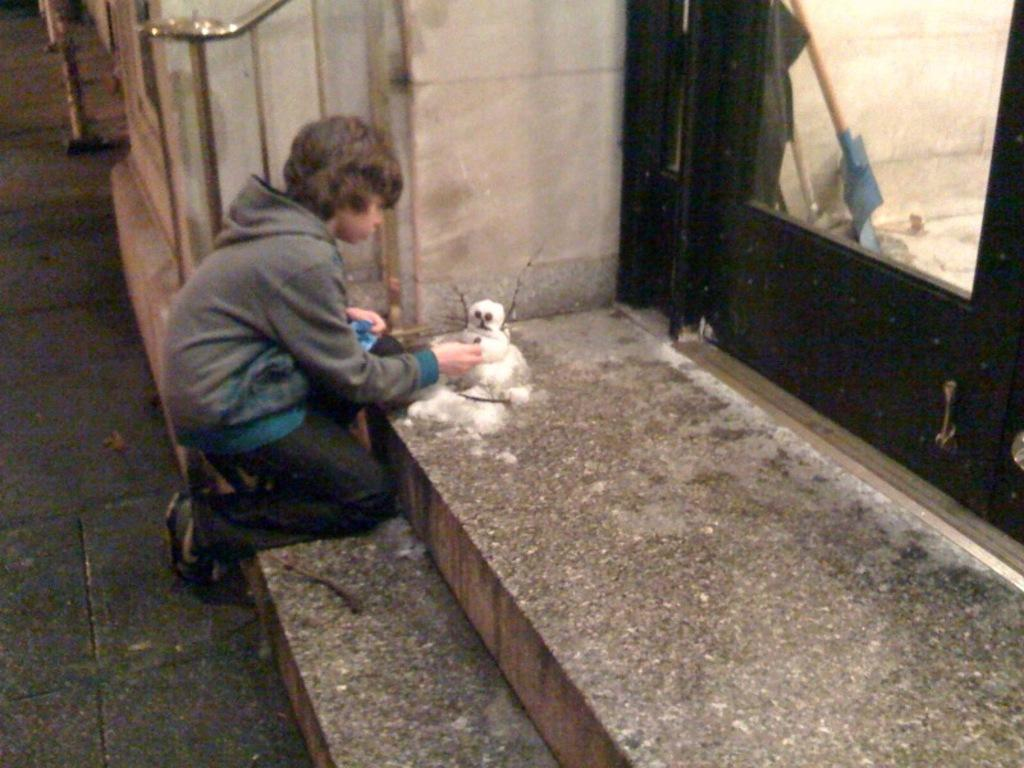What is the main subject of the image? There is a kid in the center of the image. What is the kid holding in the image? The kid is holding some objects. What is in front of the kid? There is a snowman in front of the kid. What can be seen in the background of the image? There is a wall and other objects visible in the background. What type of liquid is being used to draw on the wall in the image? There is no liquid being used to draw on the wall in the image. What kind of chalk is the kid using to draw the snowman? There is no chalk present in the image; the snowman is a separate entity. What type of leather material is visible on the kid's clothing in the image? There is no leather material visible on the kid's clothing in the image. 